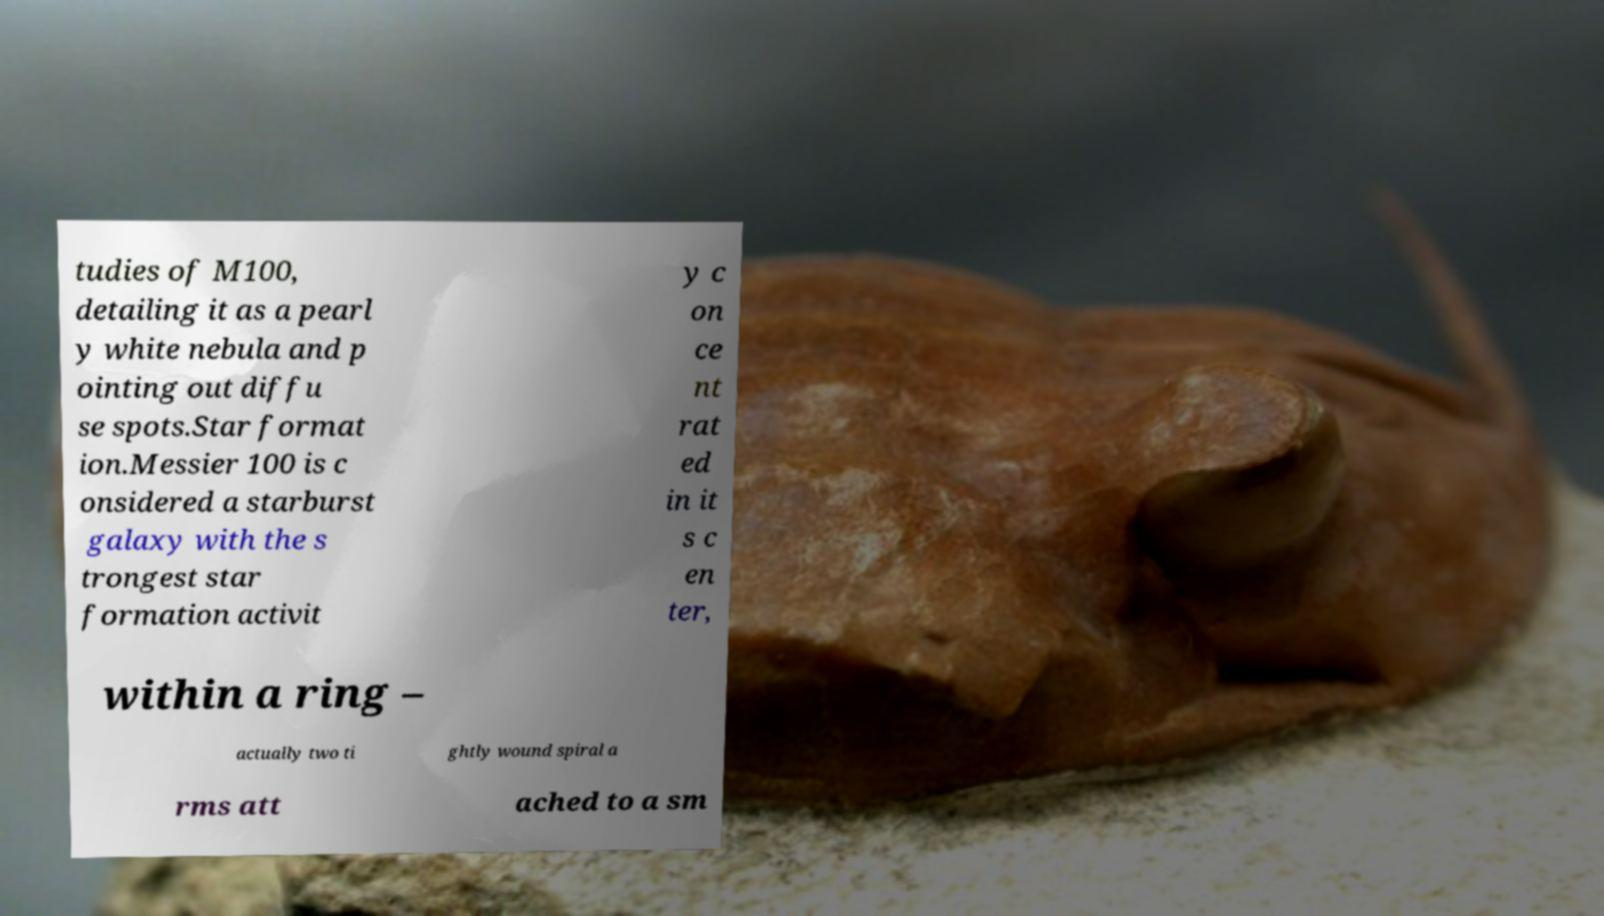Can you read and provide the text displayed in the image?This photo seems to have some interesting text. Can you extract and type it out for me? tudies of M100, detailing it as a pearl y white nebula and p ointing out diffu se spots.Star format ion.Messier 100 is c onsidered a starburst galaxy with the s trongest star formation activit y c on ce nt rat ed in it s c en ter, within a ring – actually two ti ghtly wound spiral a rms att ached to a sm 